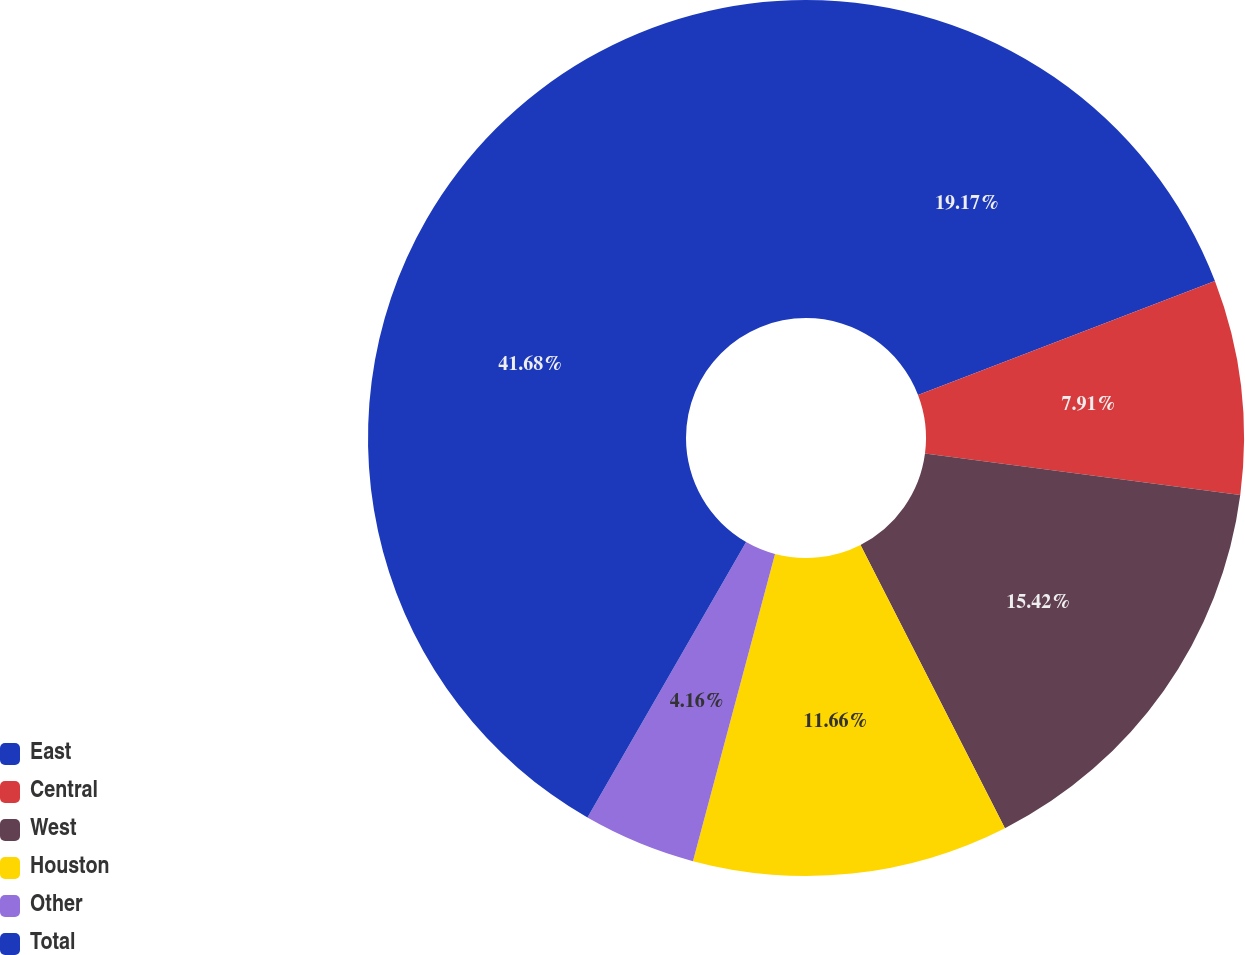Convert chart to OTSL. <chart><loc_0><loc_0><loc_500><loc_500><pie_chart><fcel>East<fcel>Central<fcel>West<fcel>Houston<fcel>Other<fcel>Total<nl><fcel>19.17%<fcel>7.91%<fcel>15.42%<fcel>11.66%<fcel>4.16%<fcel>41.69%<nl></chart> 